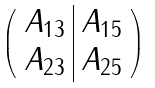<formula> <loc_0><loc_0><loc_500><loc_500>\left ( \begin{array} { c | c } A _ { 1 3 } & A _ { 1 5 } \\ A _ { 2 3 } & A _ { 2 5 } \\ \end{array} \right )</formula> 